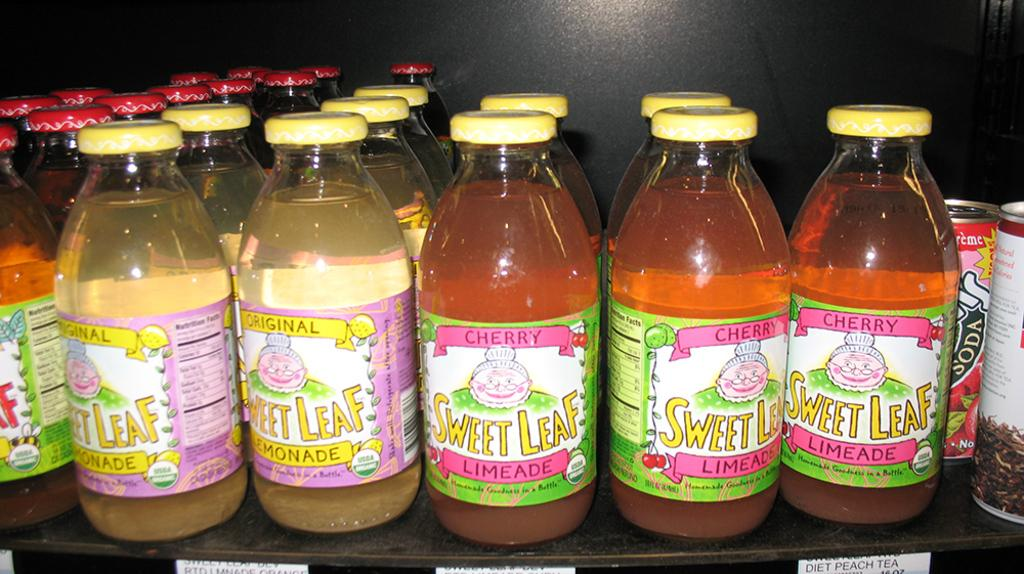<image>
Describe the image concisely. A number of bottles istting ona table with the label saying: "Sweet Leaf Limeade" 